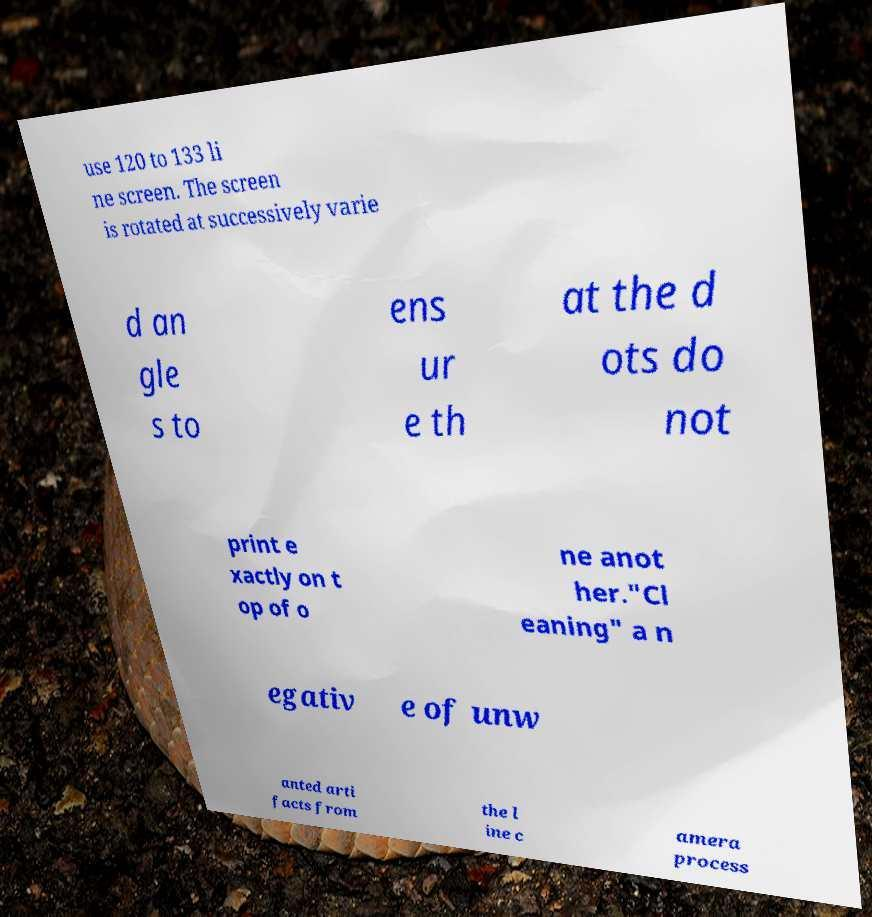Could you extract and type out the text from this image? use 120 to 133 li ne screen. The screen is rotated at successively varie d an gle s to ens ur e th at the d ots do not print e xactly on t op of o ne anot her."Cl eaning" a n egativ e of unw anted arti facts from the l ine c amera process 